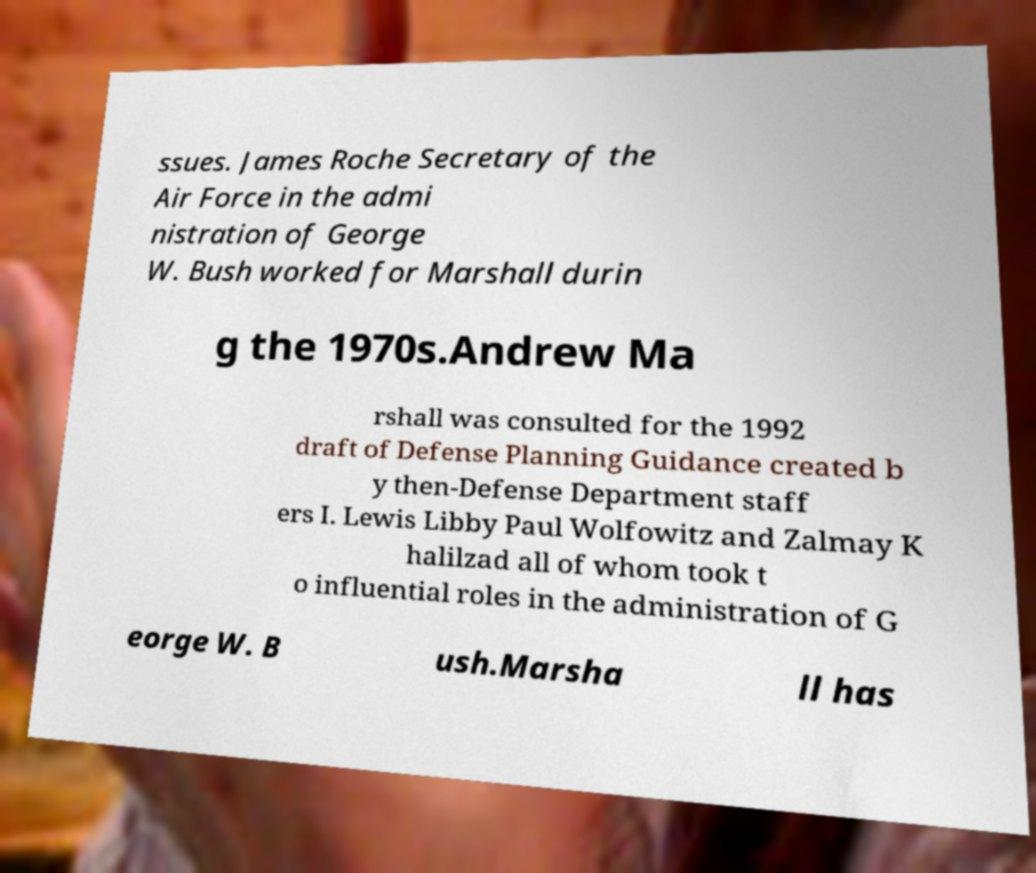There's text embedded in this image that I need extracted. Can you transcribe it verbatim? ssues. James Roche Secretary of the Air Force in the admi nistration of George W. Bush worked for Marshall durin g the 1970s.Andrew Ma rshall was consulted for the 1992 draft of Defense Planning Guidance created b y then-Defense Department staff ers I. Lewis Libby Paul Wolfowitz and Zalmay K halilzad all of whom took t o influential roles in the administration of G eorge W. B ush.Marsha ll has 